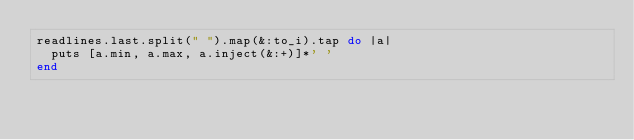<code> <loc_0><loc_0><loc_500><loc_500><_Ruby_>readlines.last.split(" ").map(&:to_i).tap do |a|
  puts [a.min, a.max, a.inject(&:+)]*' '
end</code> 